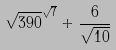<formula> <loc_0><loc_0><loc_500><loc_500>\sqrt { 3 9 0 } ^ { \sqrt { 7 } } + \frac { 6 } { \sqrt { 1 0 } }</formula> 